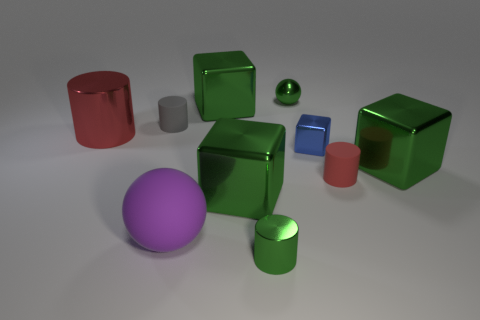Is there anything else that is the same shape as the tiny red matte thing?
Offer a terse response. Yes. How many things are either tiny blue matte spheres or tiny green shiny cylinders?
Your answer should be very brief. 1. There is a red shiny thing; is it the same shape as the tiny green shiny object in front of the matte ball?
Make the answer very short. Yes. There is a matte thing left of the large purple thing; what shape is it?
Ensure brevity in your answer.  Cylinder. Is the shape of the tiny gray rubber object the same as the big red thing?
Provide a succinct answer. Yes. The green object that is the same shape as the large red metallic thing is what size?
Provide a short and direct response. Small. There is a red thing to the left of the gray rubber object; is it the same size as the big rubber object?
Ensure brevity in your answer.  Yes. How big is the metal object that is in front of the gray matte thing and behind the blue object?
Your answer should be compact. Large. There is a sphere that is the same color as the small metal cylinder; what material is it?
Keep it short and to the point. Metal. What number of big cubes have the same color as the small ball?
Your answer should be very brief. 3. 